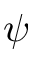<formula> <loc_0><loc_0><loc_500><loc_500>\psi</formula> 